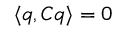<formula> <loc_0><loc_0><loc_500><loc_500>\langle q , C q \rangle = 0</formula> 